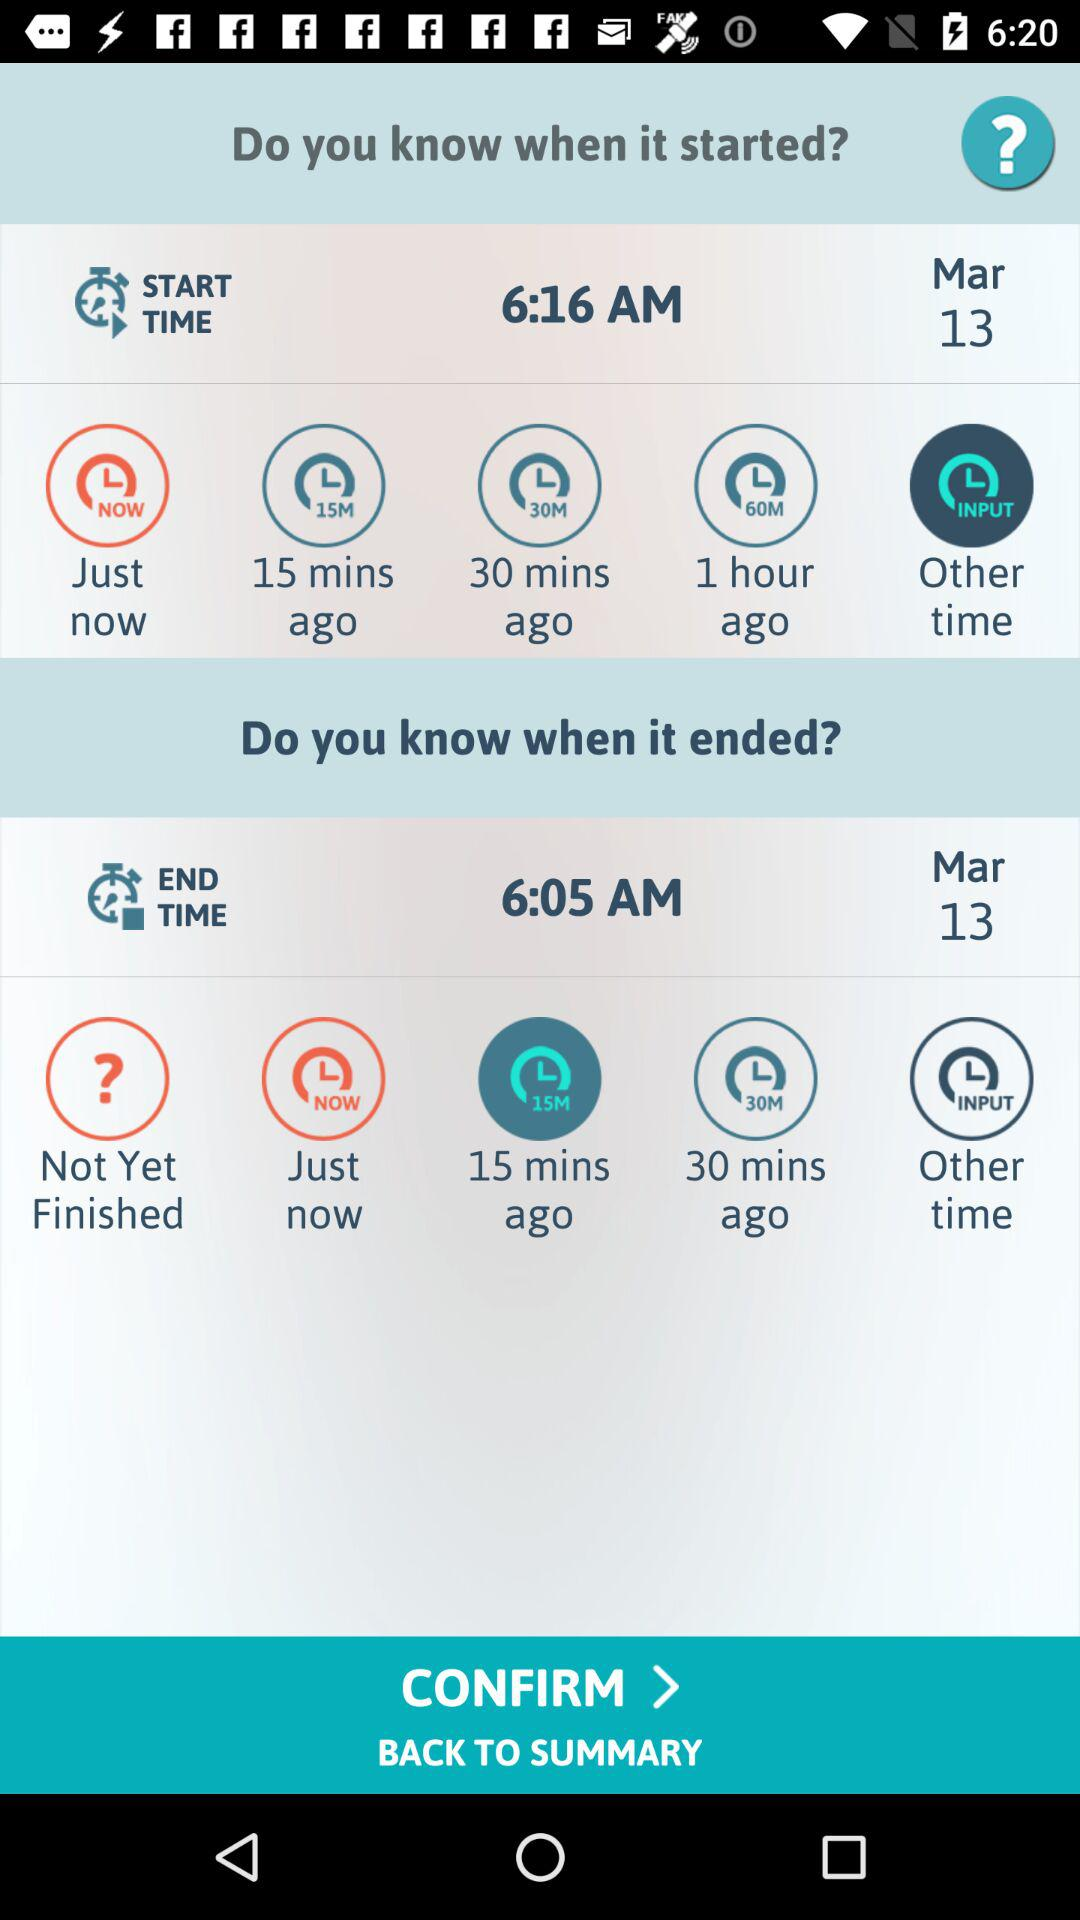What is the end time? The end time is 6:05 AM. 